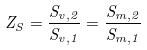<formula> <loc_0><loc_0><loc_500><loc_500>Z _ { S } = \frac { S _ { v , 2 } } { S _ { v , 1 } } = \frac { S _ { m , 2 } } { S _ { m , 1 } }</formula> 